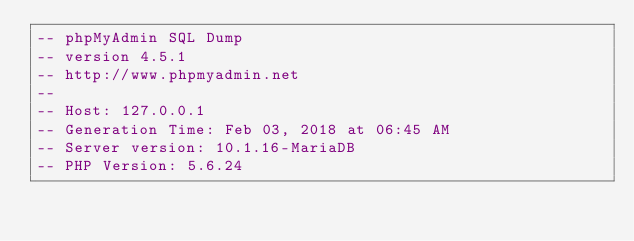Convert code to text. <code><loc_0><loc_0><loc_500><loc_500><_SQL_>-- phpMyAdmin SQL Dump
-- version 4.5.1
-- http://www.phpmyadmin.net
--
-- Host: 127.0.0.1
-- Generation Time: Feb 03, 2018 at 06:45 AM
-- Server version: 10.1.16-MariaDB
-- PHP Version: 5.6.24
</code> 